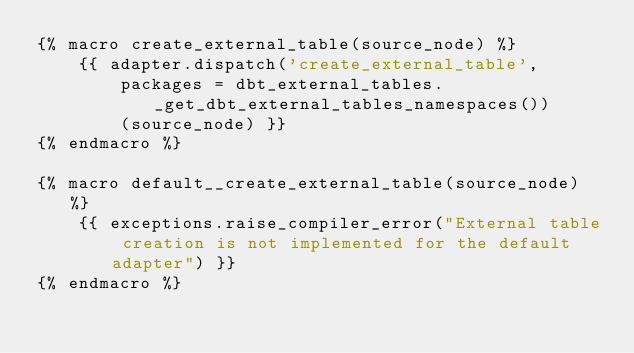Convert code to text. <code><loc_0><loc_0><loc_500><loc_500><_SQL_>{% macro create_external_table(source_node) %}
    {{ adapter.dispatch('create_external_table', 
        packages = dbt_external_tables._get_dbt_external_tables_namespaces()) 
        (source_node) }}
{% endmacro %}

{% macro default__create_external_table(source_node) %}
    {{ exceptions.raise_compiler_error("External table creation is not implemented for the default adapter") }}
{% endmacro %}
</code> 